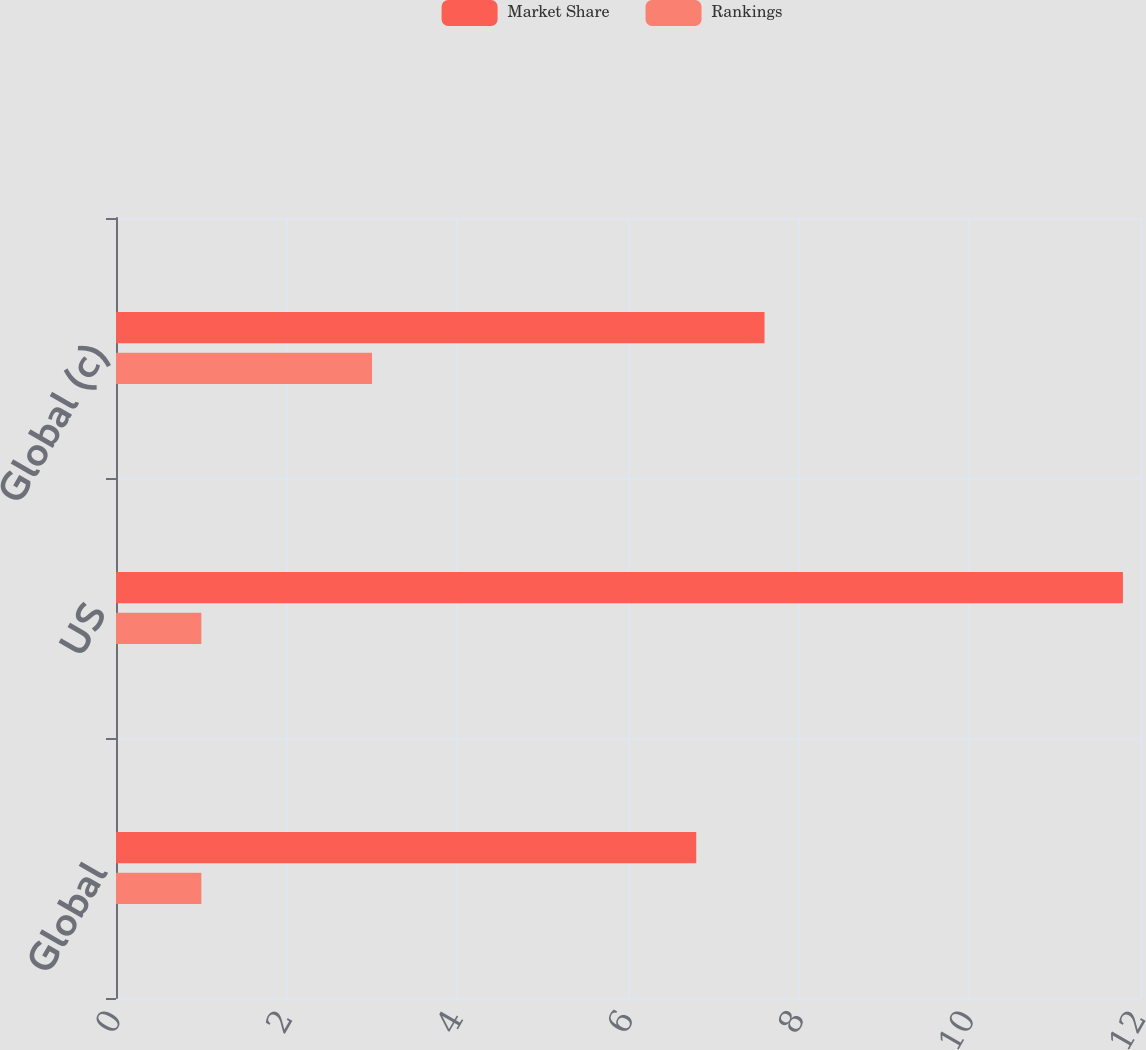<chart> <loc_0><loc_0><loc_500><loc_500><stacked_bar_chart><ecel><fcel>Global<fcel>US<fcel>Global (c)<nl><fcel>Market Share<fcel>6.8<fcel>11.8<fcel>7.6<nl><fcel>Rankings<fcel>1<fcel>1<fcel>3<nl></chart> 